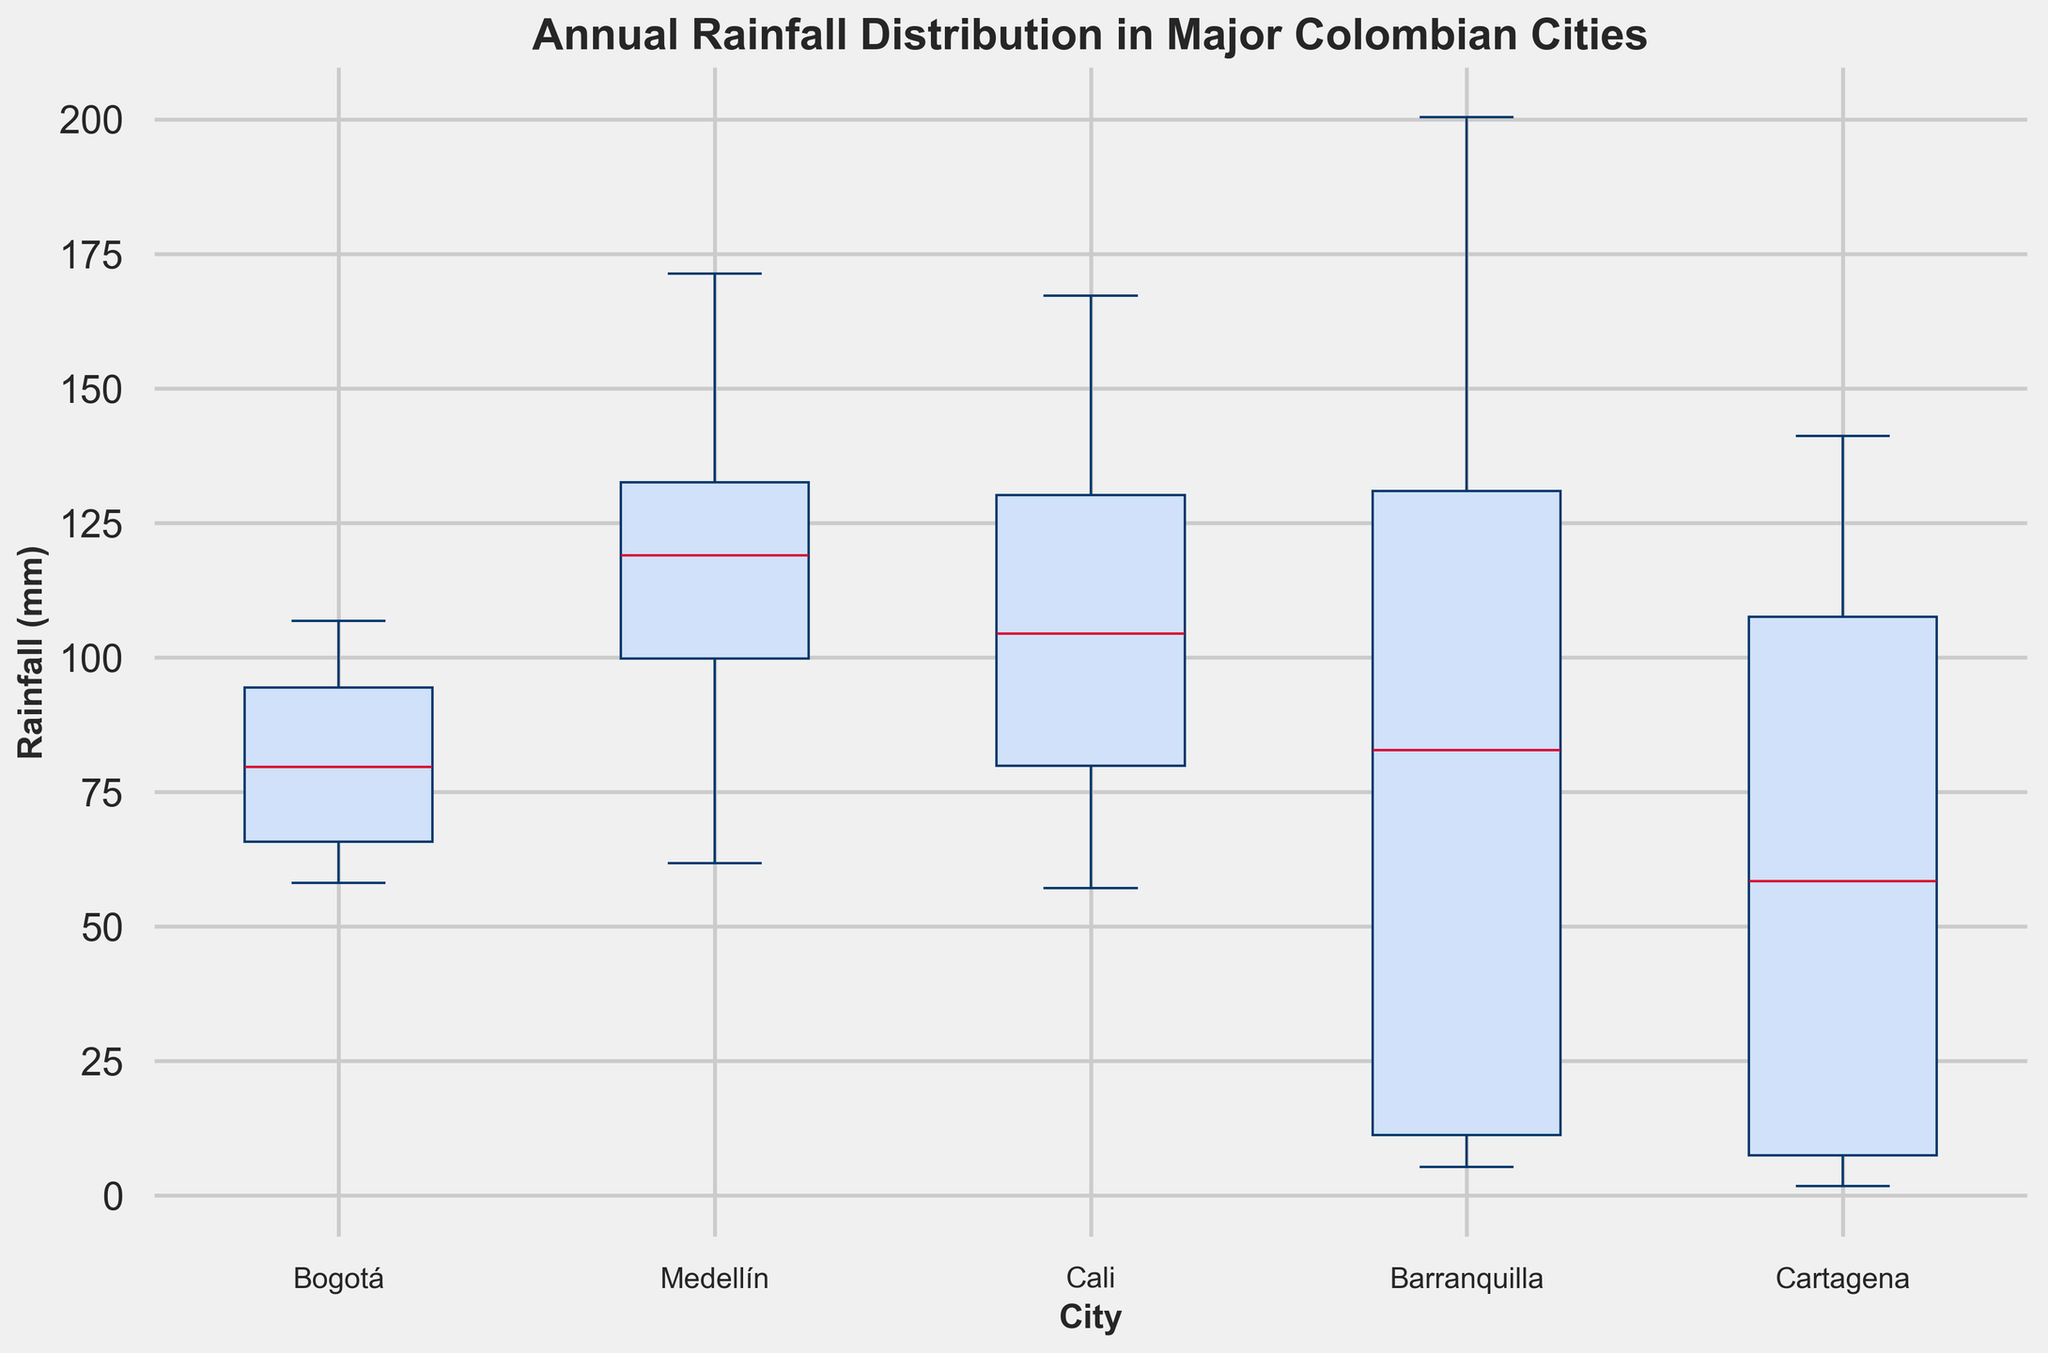Which city has the highest median annual rainfall? From the box plot, the city with the highest median line in the box plot represents the highest median annual rainfall.
Answer: Medellín Which city has the lowest median annual rainfall? From the box plot, the city with the lowest median line in the box plot represents the lowest median annual rainfall.
Answer: Cartagena What is the range of the annual rainfall distribution in Barranquilla? The range is calculated by subtracting the minimum value (bottom whisker) from the maximum value (top whisker) in the box plot for Barranquilla.
Answer: 195.1 mm Which city has the widest interquartile range (IQR) of rainfall? The IQR can be visualized as the height of the box. The city with the tallest box has the widest IQR.
Answer: Barranquilla Comparing Bogotá and Cali, which city has a higher maximum annual rainfall? By observing the top whiskers of the box plots for Bogotá and Cali, the city with the higher top whisker value has the higher maximum annual rainfall.
Answer: Cali Which city has the smallest interquartile range (IQR) of rainfall? The IQR can be visualized as the height of the box. The city with the shortest box has the smallest IQR.
Answer: Cartagena What is the median annual rainfall in Cali in millimeters? Find the median line within the box plot for Cali.
Answer: Approximately 105 mm Comparing Medellín and Barranquilla, which city has a smaller range of annual rainfall? The range is calculated by subtracting the minimum value from the maximum value. The city with the smaller difference between its top and bottom whiskers has the smaller range.
Answer: Medellín How does the variability of rainfall in Cartagena compare to that in Bogotá? Variability can be assessed by comparing the IQR and the range of the box plots. Cartagena has a shorter box and shorter whiskers compared to Bogotá, indicating less variability.
Answer: Cartagena has less variability Which city has the highest variability in annual rainfall? The city with the largest range (difference between top and bottom whiskers) indicates the highest variability.
Answer: Barranquilla 